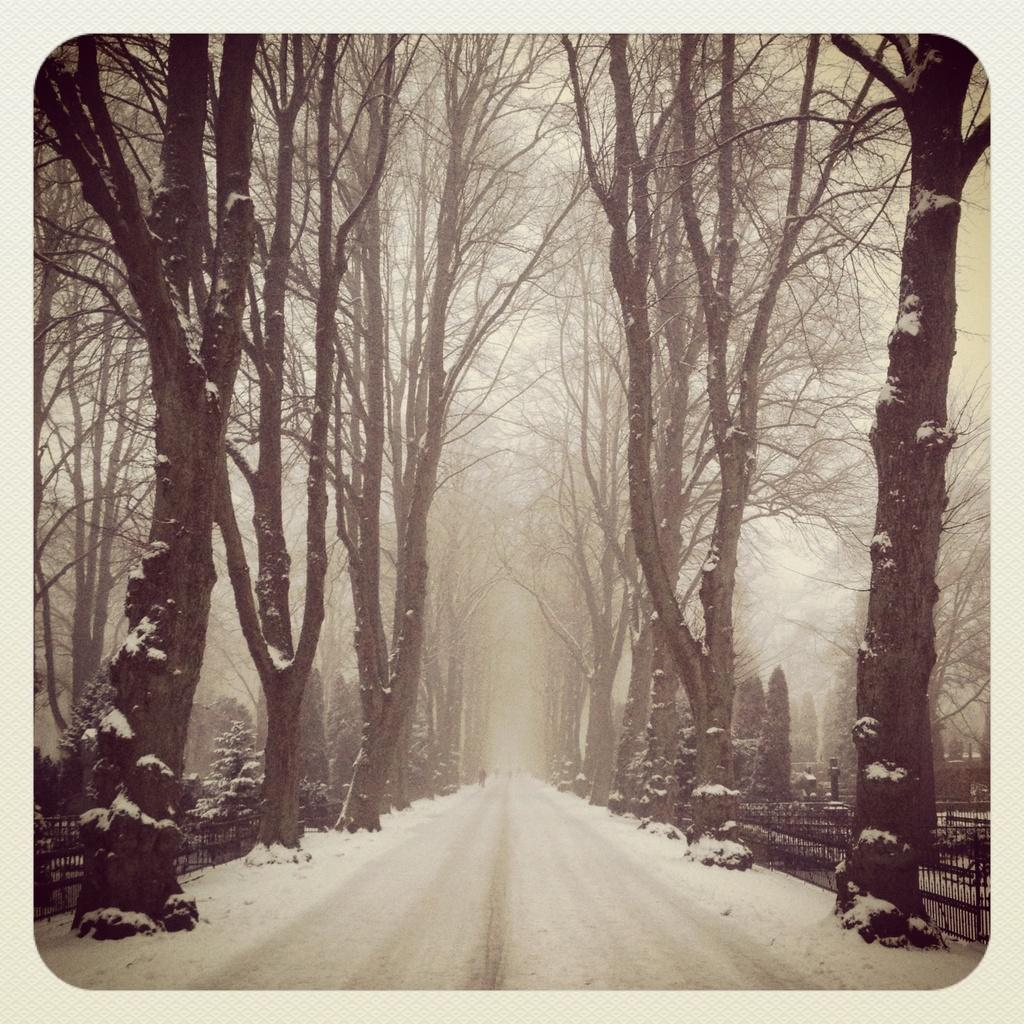What is the person in the image doing? There is a person on the road in the image, but their activity is not specified. What type of vegetation is present in the image? There are trees in the image. What is the weather like in the image? There is snow visible in the image, suggesting a cold or wintry environment. What structure can be seen in the image? There is a pole in the image. What type of barrier is present in the image? There is a fence in the image. What type of underwear is the person wearing in the image? There is no information about the person's underwear in the image. What type of plants are growing on the table in the image? There is no table or plants growing on a table in the image. 